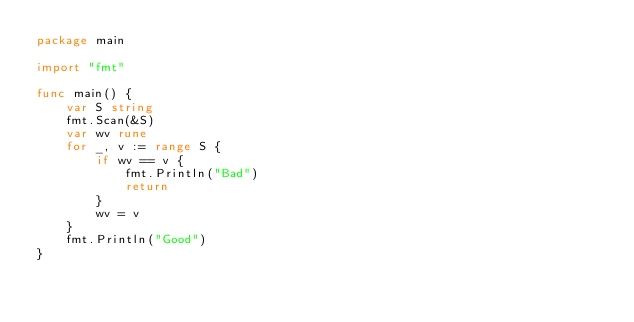<code> <loc_0><loc_0><loc_500><loc_500><_Go_>package main

import "fmt"

func main() {
	var S string
	fmt.Scan(&S)
	var wv rune
	for _, v := range S {
		if wv == v {
			fmt.Println("Bad")
			return
		}
		wv = v
	}
	fmt.Println("Good")
}</code> 